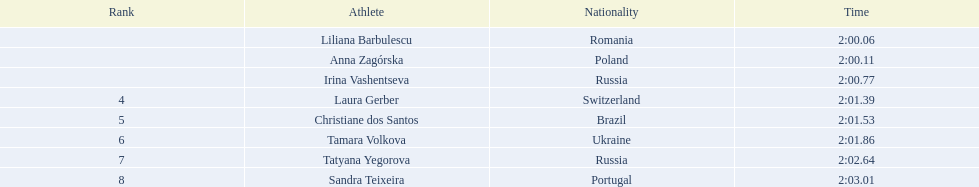Who are all of the athletes? Liliana Barbulescu, Anna Zagórska, Irina Vashentseva, Laura Gerber, Christiane dos Santos, Tamara Volkova, Tatyana Yegorova, Sandra Teixeira. What were their times in the heat? 2:00.06, 2:00.11, 2:00.77, 2:01.39, 2:01.53, 2:01.86, 2:02.64, 2:03.01. Of these, which is the top time? 2:00.06. Which athlete had this time? Liliana Barbulescu. What were all the finishing times? 2:00.06, 2:00.11, 2:00.77, 2:01.39, 2:01.53, 2:01.86, 2:02.64, 2:03.01. Which of these is anna zagorska's? 2:00.11. Can you provide a list of all the athletes? Liliana Barbulescu, Anna Zagórska, Irina Vashentseva, Laura Gerber, Christiane dos Santos, Tamara Volkova, Tatyana Yegorova, Sandra Teixeira. What were their individual times in the heat? 2:00.06, 2:00.11, 2:00.77, 2:01.39, 2:01.53, 2:01.86, 2:02.64, 2:03.01. Out of these times, which is the best one? 2:00.06. Who is the athlete with this top time? Liliana Barbulescu. 